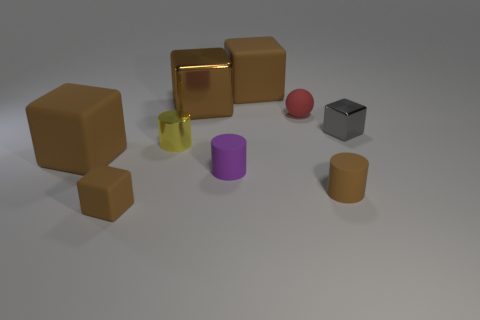What is the material of the cylinder that is the same color as the tiny rubber block?
Provide a short and direct response. Rubber. How many other things are there of the same material as the purple cylinder?
Keep it short and to the point. 5. Is the number of blocks behind the tiny yellow cylinder the same as the number of purple things on the left side of the brown metal object?
Provide a short and direct response. No. What color is the large rubber thing on the left side of the tiny brown matte object to the left of the tiny brown matte cylinder in front of the shiny cylinder?
Your answer should be very brief. Brown. There is a rubber thing that is to the left of the small brown block; what is its shape?
Your answer should be compact. Cube. There is a purple object that is the same material as the tiny red thing; what shape is it?
Give a very brief answer. Cylinder. Is there anything else that has the same shape as the yellow object?
Provide a succinct answer. Yes. There is a yellow cylinder; how many tiny brown objects are on the right side of it?
Your answer should be very brief. 1. Is the number of red spheres that are in front of the tiny brown matte block the same as the number of large brown shiny blocks?
Give a very brief answer. No. Do the tiny yellow thing and the ball have the same material?
Your response must be concise. No. 